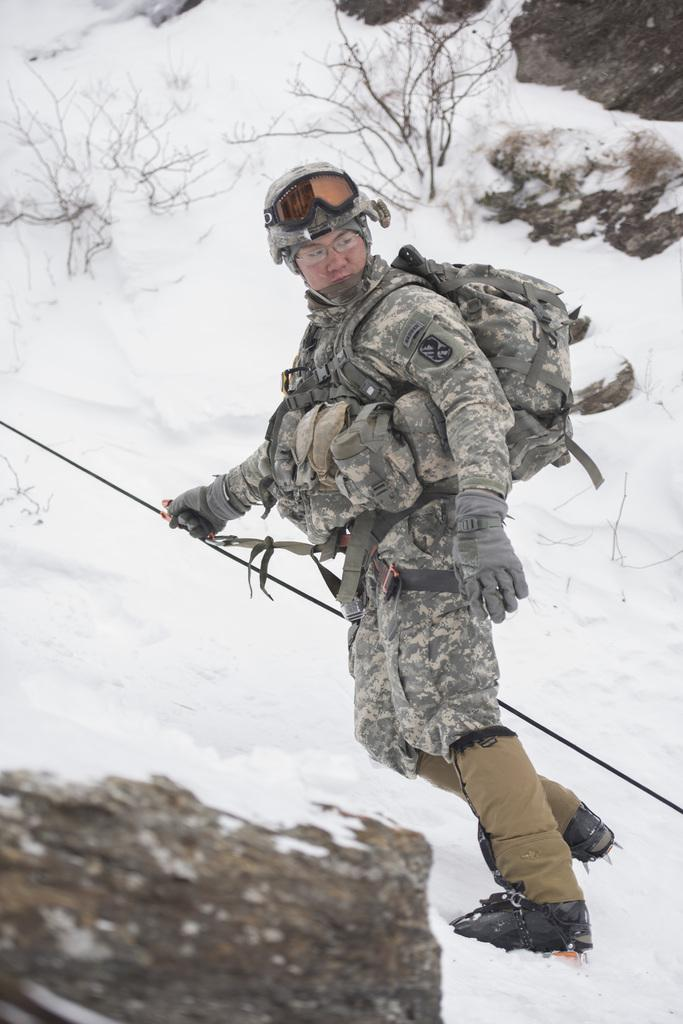Who or what is present in the image? There is a person in the image. What is the person wearing? The person is wearing objects. What is the person holding in the image? The person is holding an object. What type of natural elements can be seen in the snow? There are rocks and twigs in the snow. What type of humor can be seen in the person's thought bubble in the image? There is no humor or thought bubble present in the image. 